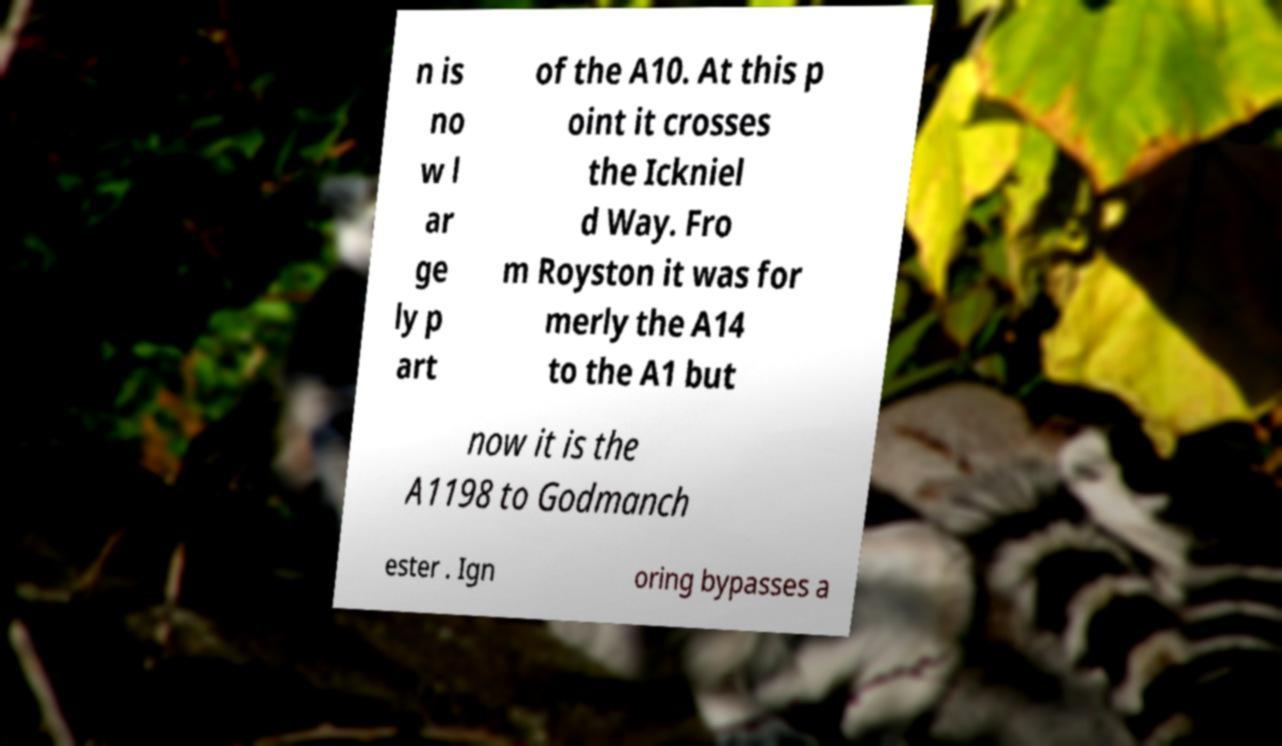Can you read and provide the text displayed in the image?This photo seems to have some interesting text. Can you extract and type it out for me? n is no w l ar ge ly p art of the A10. At this p oint it crosses the Ickniel d Way. Fro m Royston it was for merly the A14 to the A1 but now it is the A1198 to Godmanch ester . Ign oring bypasses a 